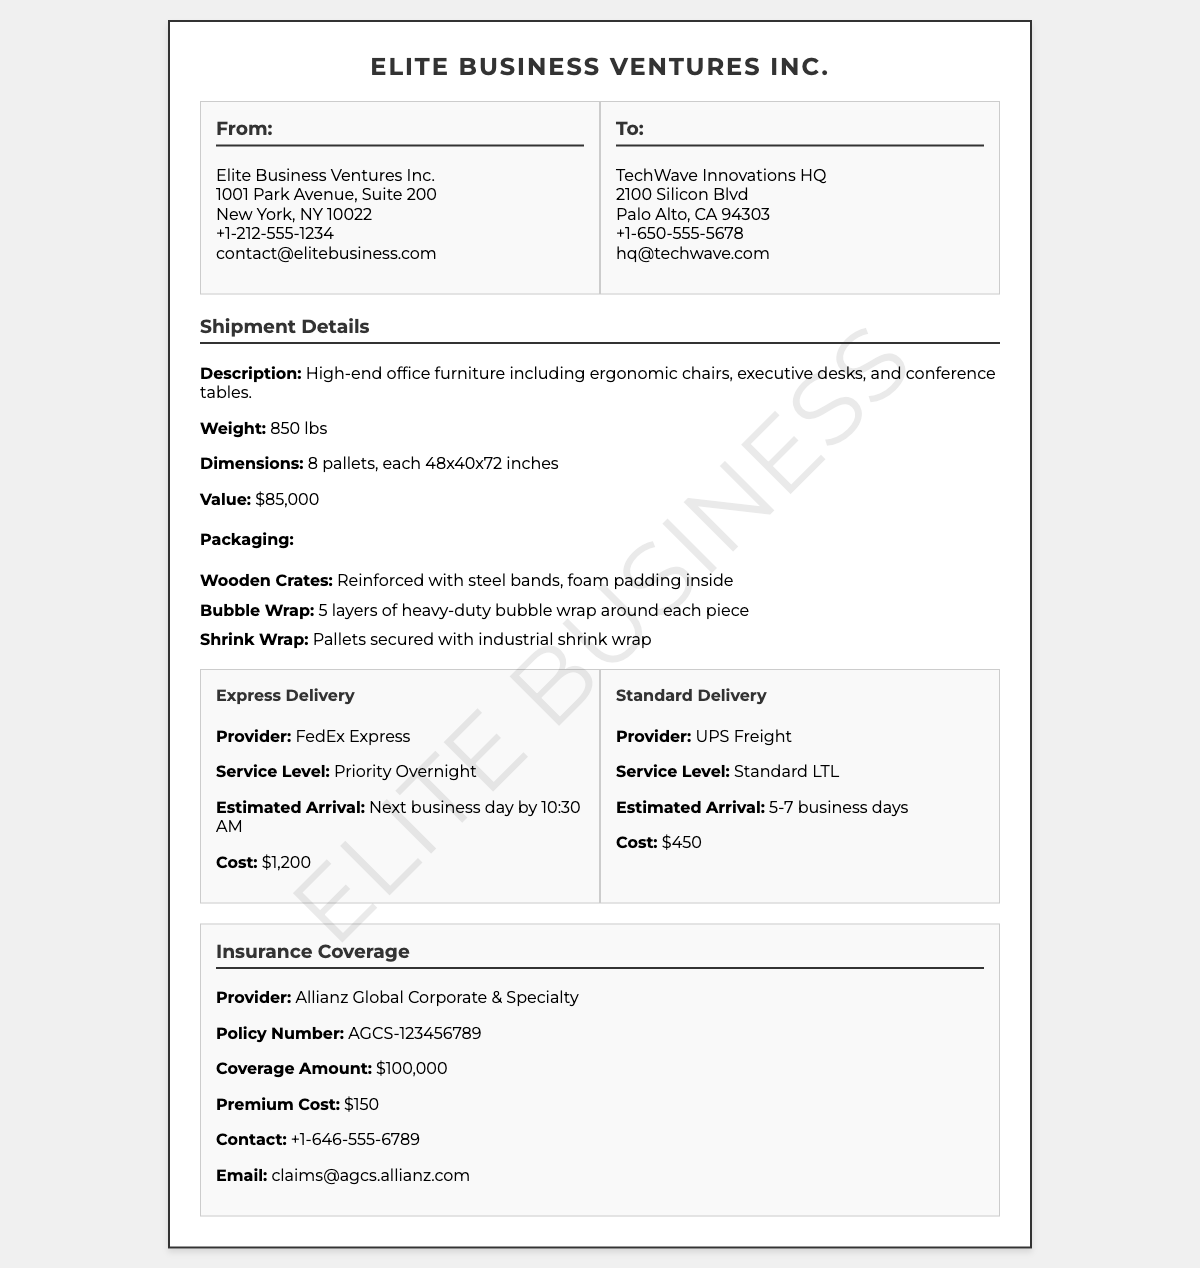What is the total weight of the shipment? The total weight of the shipment is stated directly in the document, which is 850 lbs.
Answer: 850 lbs Who is the shipping provider for Express Delivery? The document specifies the provider for Express Delivery under the corresponding section, which is FedEx Express.
Answer: FedEx Express What is the coverage amount for the insurance? The coverage amount is detailed under the Insurance Coverage section, which clearly indicates $100,000.
Answer: $100,000 What is the estimated arrival time for Standard Delivery? The expected arrival time is mentioned in the Standard Delivery option, which is 5-7 business days.
Answer: 5-7 business days What type of packaging is used for the shipment? The document lists the types of packaging in the shipment details, which includes wooden crates, bubble wrap, and shrink wrap.
Answer: Wooden Crates, Bubble Wrap, Shrink Wrap What is the cost of Express Delivery? The cost is provided in the Express Delivery section, which states $1,200.
Answer: $1,200 What is the contact email for the insurance provider? The contact email is listed in the Insurance Coverage section, noted as claims@agcs.allianz.com.
Answer: claims@agcs.allianz.com Which items are included in the shipment? The shipment description specifies the included items which are ergonomic chairs, executive desks, and conference tables.
Answer: Ergonomic chairs, executive desks, conference tables What is the premium cost for the insurance? The premium cost is specified in the insurance section, which is $150.
Answer: $150 